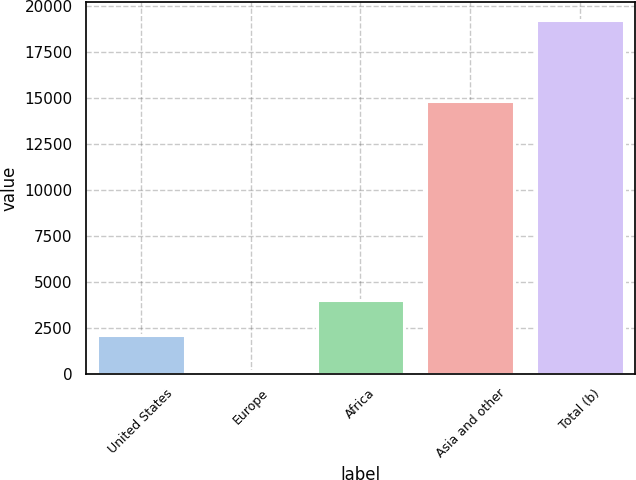<chart> <loc_0><loc_0><loc_500><loc_500><bar_chart><fcel>United States<fcel>Europe<fcel>Africa<fcel>Asia and other<fcel>Total (b)<nl><fcel>2077.8<fcel>169<fcel>3986.6<fcel>14845<fcel>19257<nl></chart> 